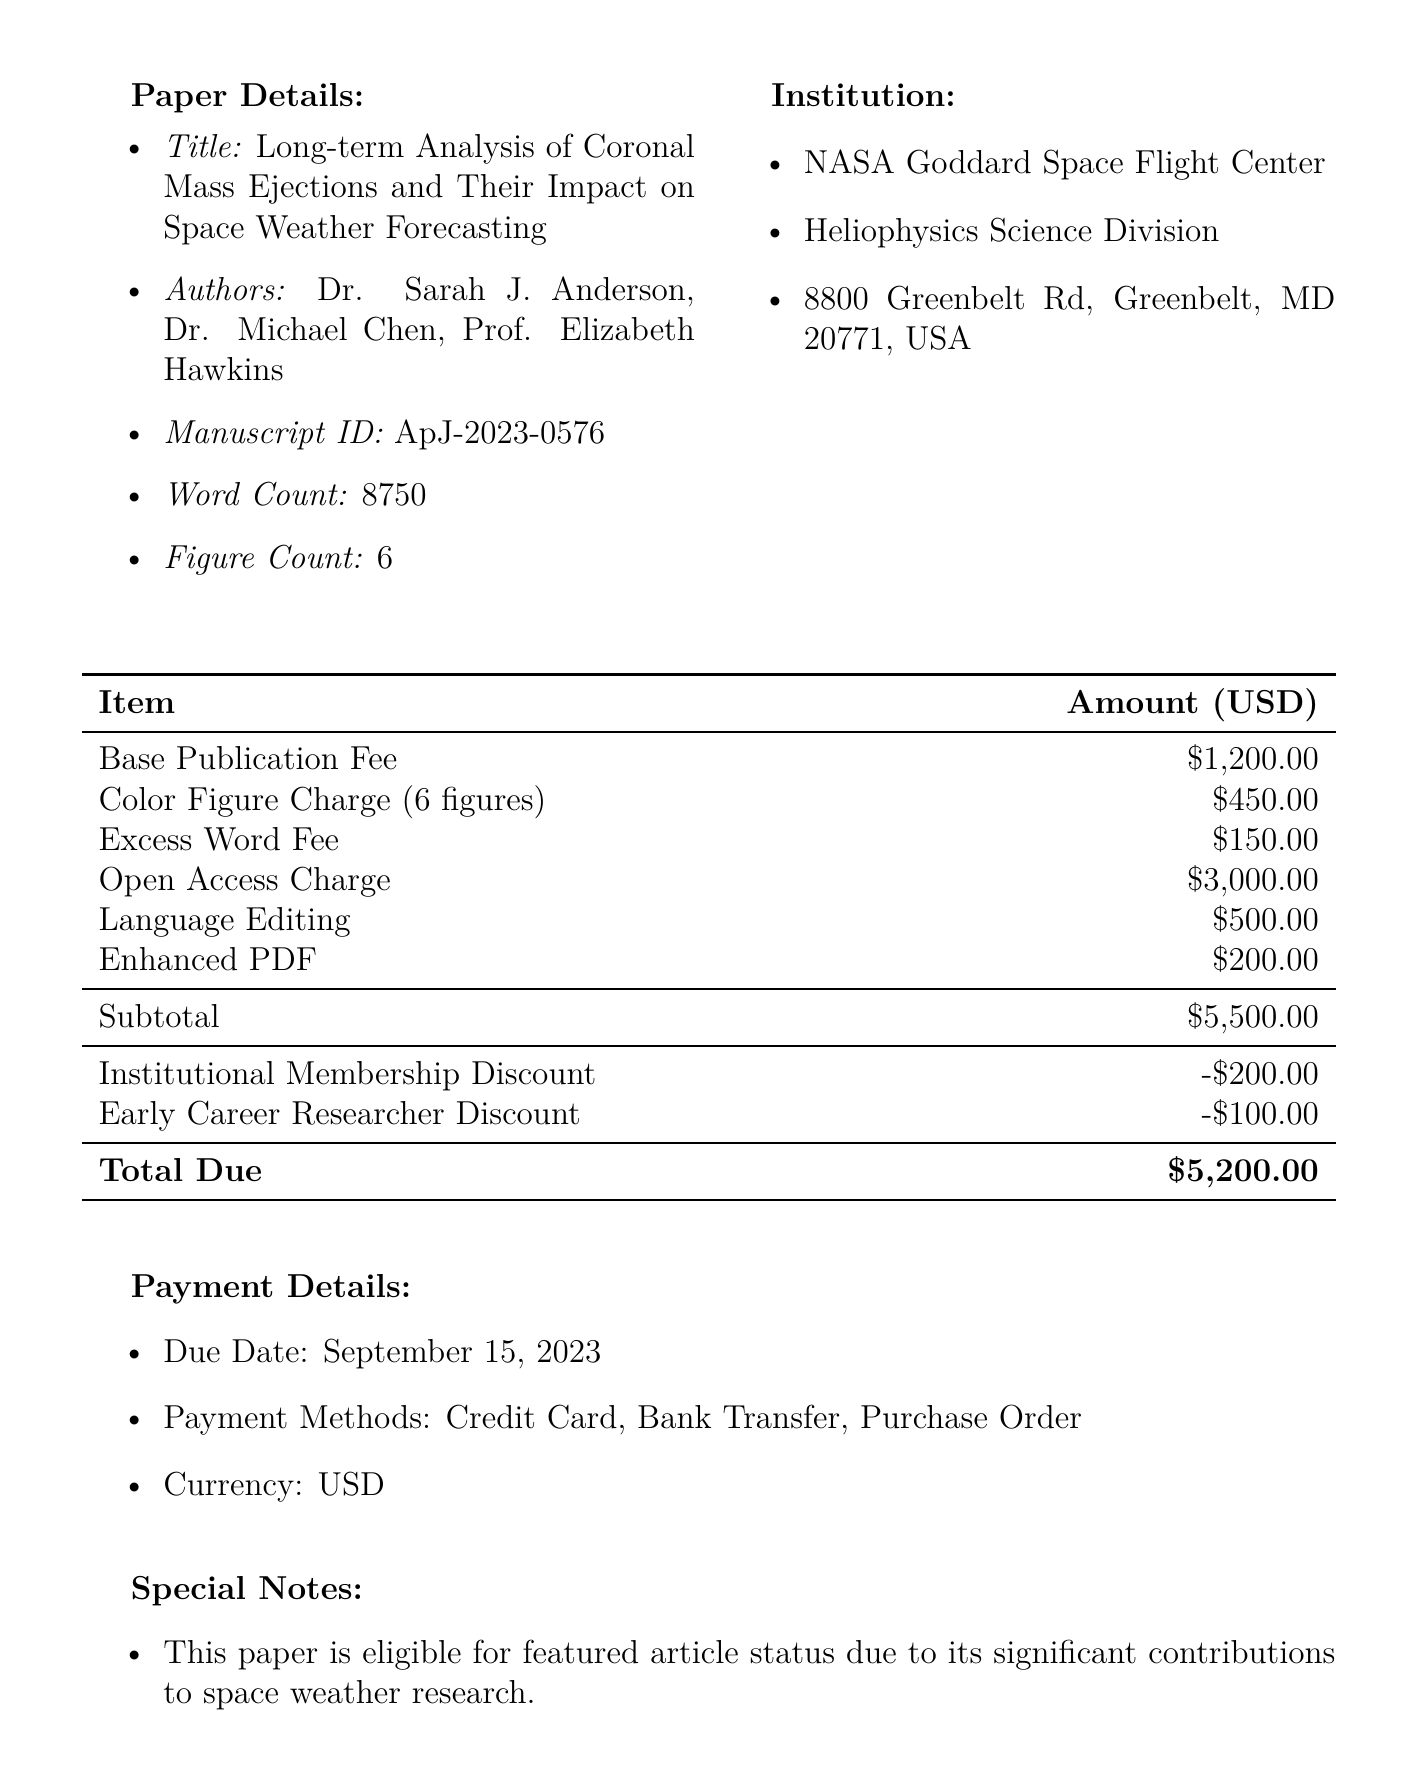What is the title of the paper? The title of the paper is specifically listed in the document.
Answer: Long-term Analysis of Coronal Mass Ejections and Their Impact on Space Weather Forecasting Who is the corresponding editor? The document includes the name of the editor responsible for the publication.
Answer: Dr. Jennifer Liu What is the base publication fee? The base publication fee is mentioned as a distinct cost in the fees section.
Answer: $1,200.00 What are the total due fees after discounts? The total due fees are calculated by taking the subtotal and subtracting the discounts listed.
Answer: $5,200.00 What is the word count of the manuscript? The word count is specified within the paper details section of the document.
Answer: 8750 How many figures are included in the paper? The document states the number of figures associated with the paper.
Answer: 6 What is the due date for payment? The due date for payment is clearly stated in the payment details section.
Answer: September 15, 2023 What optional service charge is listed for open access? The optional charge for open access is detailed in the fees section.
Answer: $3,000.00 What institution are the authors affiliated with? The institution name is provided in the document under the institution section.
Answer: NASA Goddard Space Flight Center 